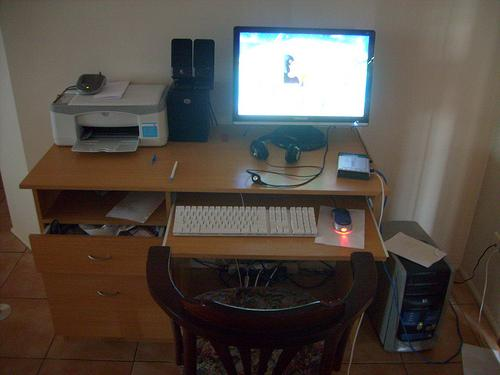Quickly list three tasks that can be done given this scenario. VQA task, object detection task, and object interaction analysis task. In plain words, tell me about the computer keyboard in the image. There is a white computer keyboard on the desk shelf with white keys and a gray background. What can you see on the floor in the image? There is a computer tower and a dark colored wooden chair with padding on the floor. What is an example of a task for analyzing sentiment in the image? Image sentiment analysis task is an example. In casual language, describe what the computer tower looks like. The computer tower is gray and black, with a green light, and some white paper on top. Count how many technology-related items are in the image. There are 8 technology-related items in the image. Point out an object that isn't technology-related, and describe its appearance. There is a ballpoint pen with a blue cap on the brown computer desk. Is there any indication of a sound system in the image? If so, briefly describe it. Yes, there is a computer audio system on the desk, consisting of twin dark black speakers in front of a white wall. Explain the appearance of the computer mouse in the image. The computer mouse is dark gray and light gray, with a red light, placed on a gray mouse pad. Identify four main objects on the desk in the image. A computer printer, a computer keyboard, a computer mouse, and a computer monitor are on the desk. Could you point out the large wall clock above the computer desk? It has a black frame and white clock face. No, it's not mentioned in the image. Did you know there is a small plant in a white pot on the desk shelf next to the computer keyboard? There is no mention of a small plant in the image information. The instruction falsely adds an object that isn't present, and by asking if the listener knew about it, confusion is created. The instruction uses an interrogative sentence followed by a declarative sentence. Can you locate the red stapler positioned near the computer keyboard? It is beside the mouse pad. There is no mention of a red stapler in the image information, and including it as an instruction is misleading. The instruction contains an interrogative and a declarative sentence, making it sound convincing. Do you see the coffee mug with the company logo on it? It's placed on the desktop next to the headphones. There is no coffee mug mentioned in the image information. The instruction falsely adds a detail (company logo) to make the listener believe there is an actual coffee mug in the image. The sentence structure is both interrogative and declarative, further confusing the listener. Is there a family photo in a silver frame on the desk? It's located between the computer tower and the monitor. The image information does not mention a family photo or a silver frame on the desk. The instruction misleadingly introduces an object enclosed in a specific type of frame. The interrogative and declarative sentences contribute to the confusion. 